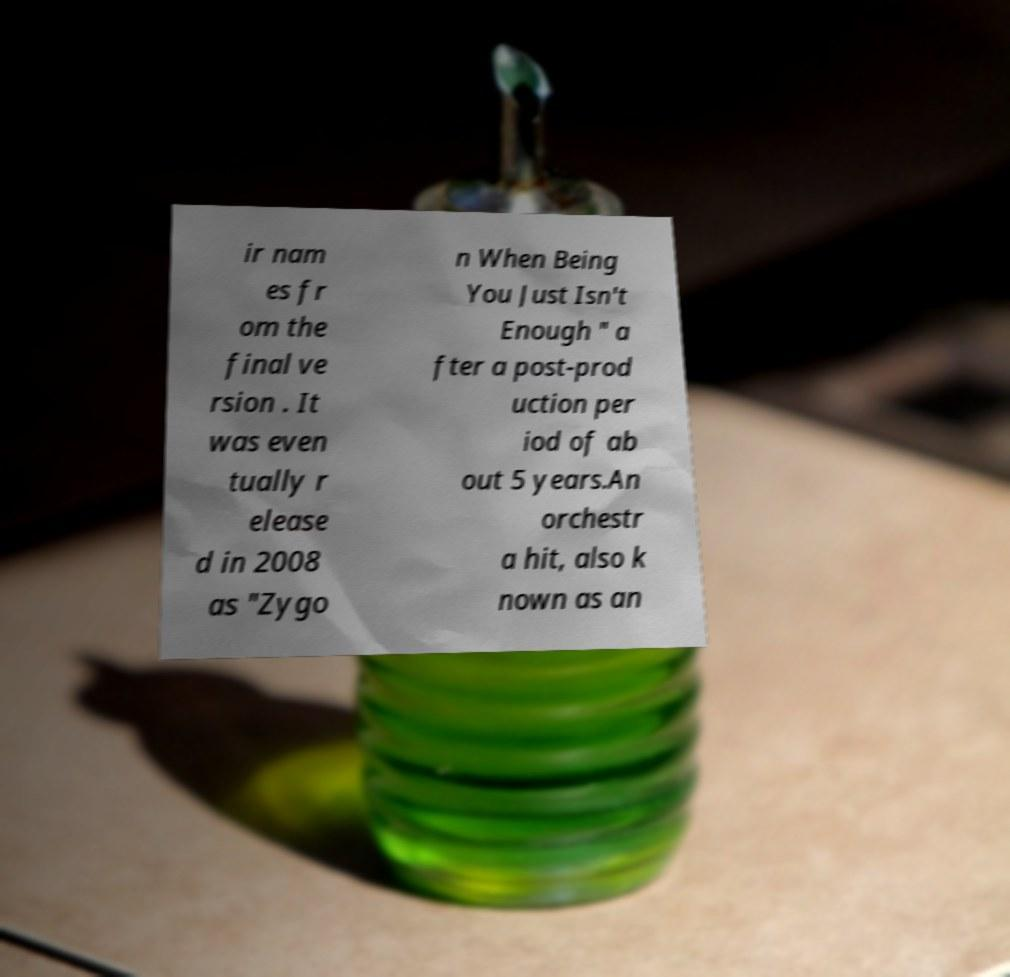Please read and relay the text visible in this image. What does it say? ir nam es fr om the final ve rsion . It was even tually r elease d in 2008 as "Zygo n When Being You Just Isn't Enough " a fter a post-prod uction per iod of ab out 5 years.An orchestr a hit, also k nown as an 